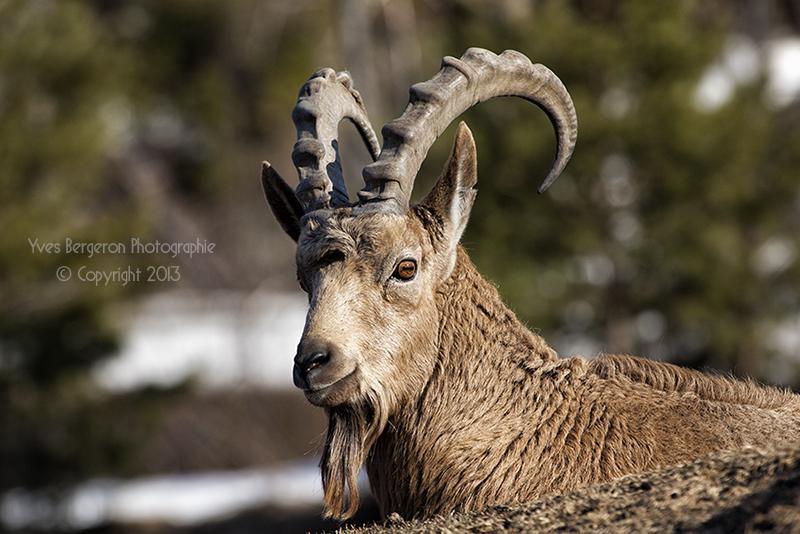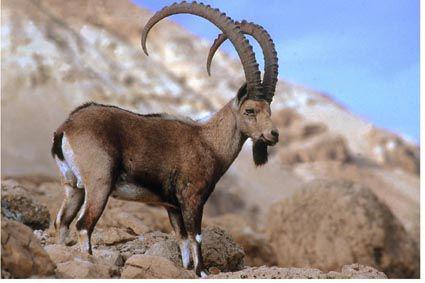The first image is the image on the left, the second image is the image on the right. Given the left and right images, does the statement "There is a total of two animals." hold true? Answer yes or no. Yes. 